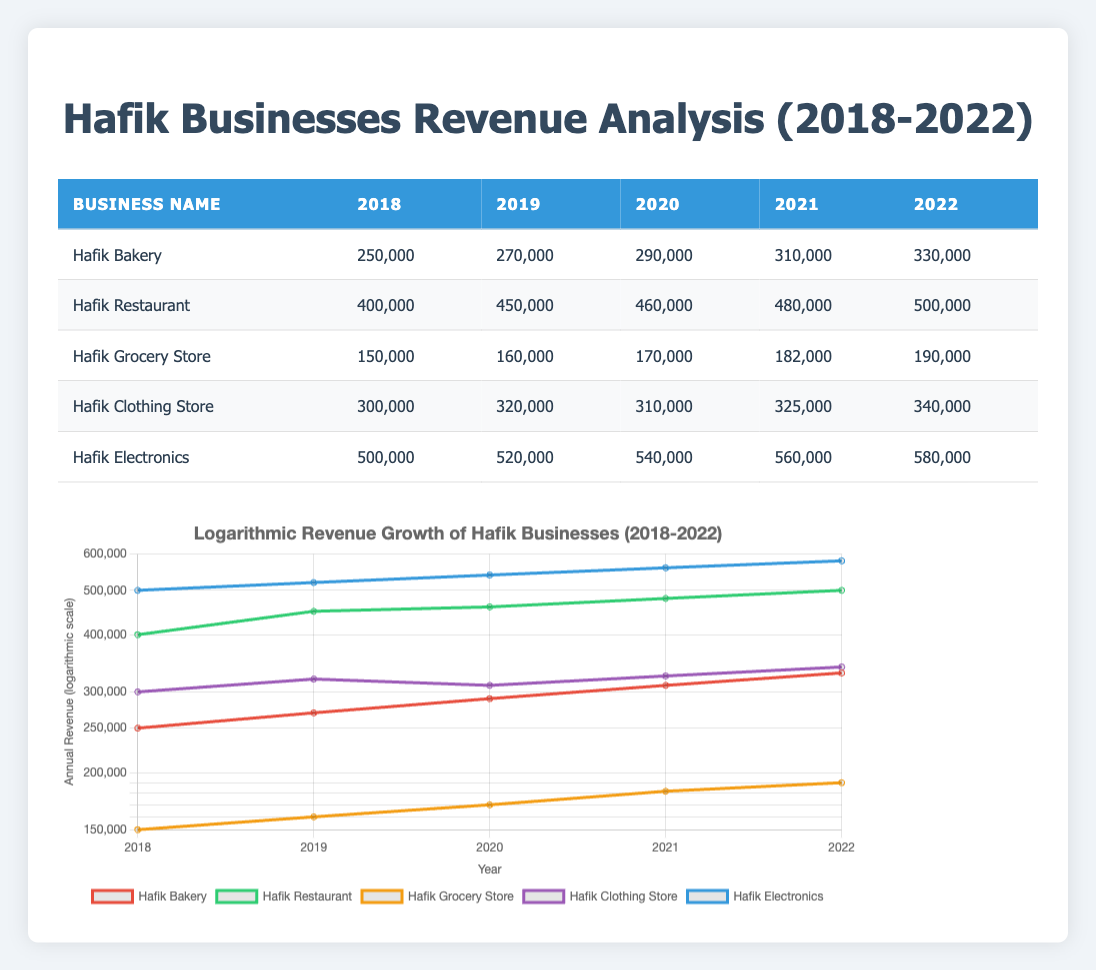What was Hafik Grocery Store’s annual revenue in 2020? The revenue for Hafik Grocery Store in 2020 is listed directly in the table. By looking at the row for Hafik Grocery Store and identifying the value for 2020, we find it is 170,000.
Answer: 170,000 Which business had the highest revenue in 2022? By examining the 2022 column for each business, we compare the revenues. Hafik Electronics shows the highest revenue at 580,000, while other businesses have lower revenues.
Answer: Hafik Electronics What was the overall revenue growth of Hafik Bakery from 2018 to 2022? First, we identify the 2018 revenue (250,000) and 2022 revenue (330,000) from Hafik Bakery's row. The growth is calculated as 330,000 - 250,000 = 80,000. This indicates an increase of 80,000 over 5 years.
Answer: 80,000 Is it true that Hafik Restaurant consistently increased its revenue every year from 2018 to 2022? By reviewing the revenues of Hafik Restaurant from 2018 to 2022, we see they increased from 400,000 to 500,000 each year without any decreases. This confirms a consistent growth each year.
Answer: Yes What is the average annual revenue for Hafik Clothing Store over the five years? To find the average revenue for Hafik Clothing Store, we add the revenues for each year: 300,000 + 320,000 + 310,000 + 325,000 + 340,000 = 1,595,000. Dividing this total by the number of years (5), we get 1,595,000 / 5 = 319,000.
Answer: 319,000 Which business had the lowest annual revenue in 2019? Looking at the 2019 column for all businesses, we see Hafik Grocery Store had the lowest revenue of 160,000 compared to all others listed for that year.
Answer: Hafik Grocery Store What was the total revenue of Hafik Electronics from 2018 to 2022? To calculate the total revenue for Hafik Electronics, we add each year’s revenue: 500,000 + 520,000 + 540,000 + 560,000 + 580,000 = 2,700,000. This gives us the overall total revenue across the five years.
Answer: 2,700,000 Did Hafik Bakery's revenue decrease in any year from 2018 to 2022? By analyzing the annual revenues listed for Hafik Bakery, we see they increased each year (from 250,000 to 330,000) without any declines, confirming there were no decreases in revenue in any year.
Answer: No 